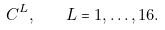Convert formula to latex. <formula><loc_0><loc_0><loc_500><loc_500>C ^ { L } , \quad L = 1 , \dots , 1 6 .</formula> 